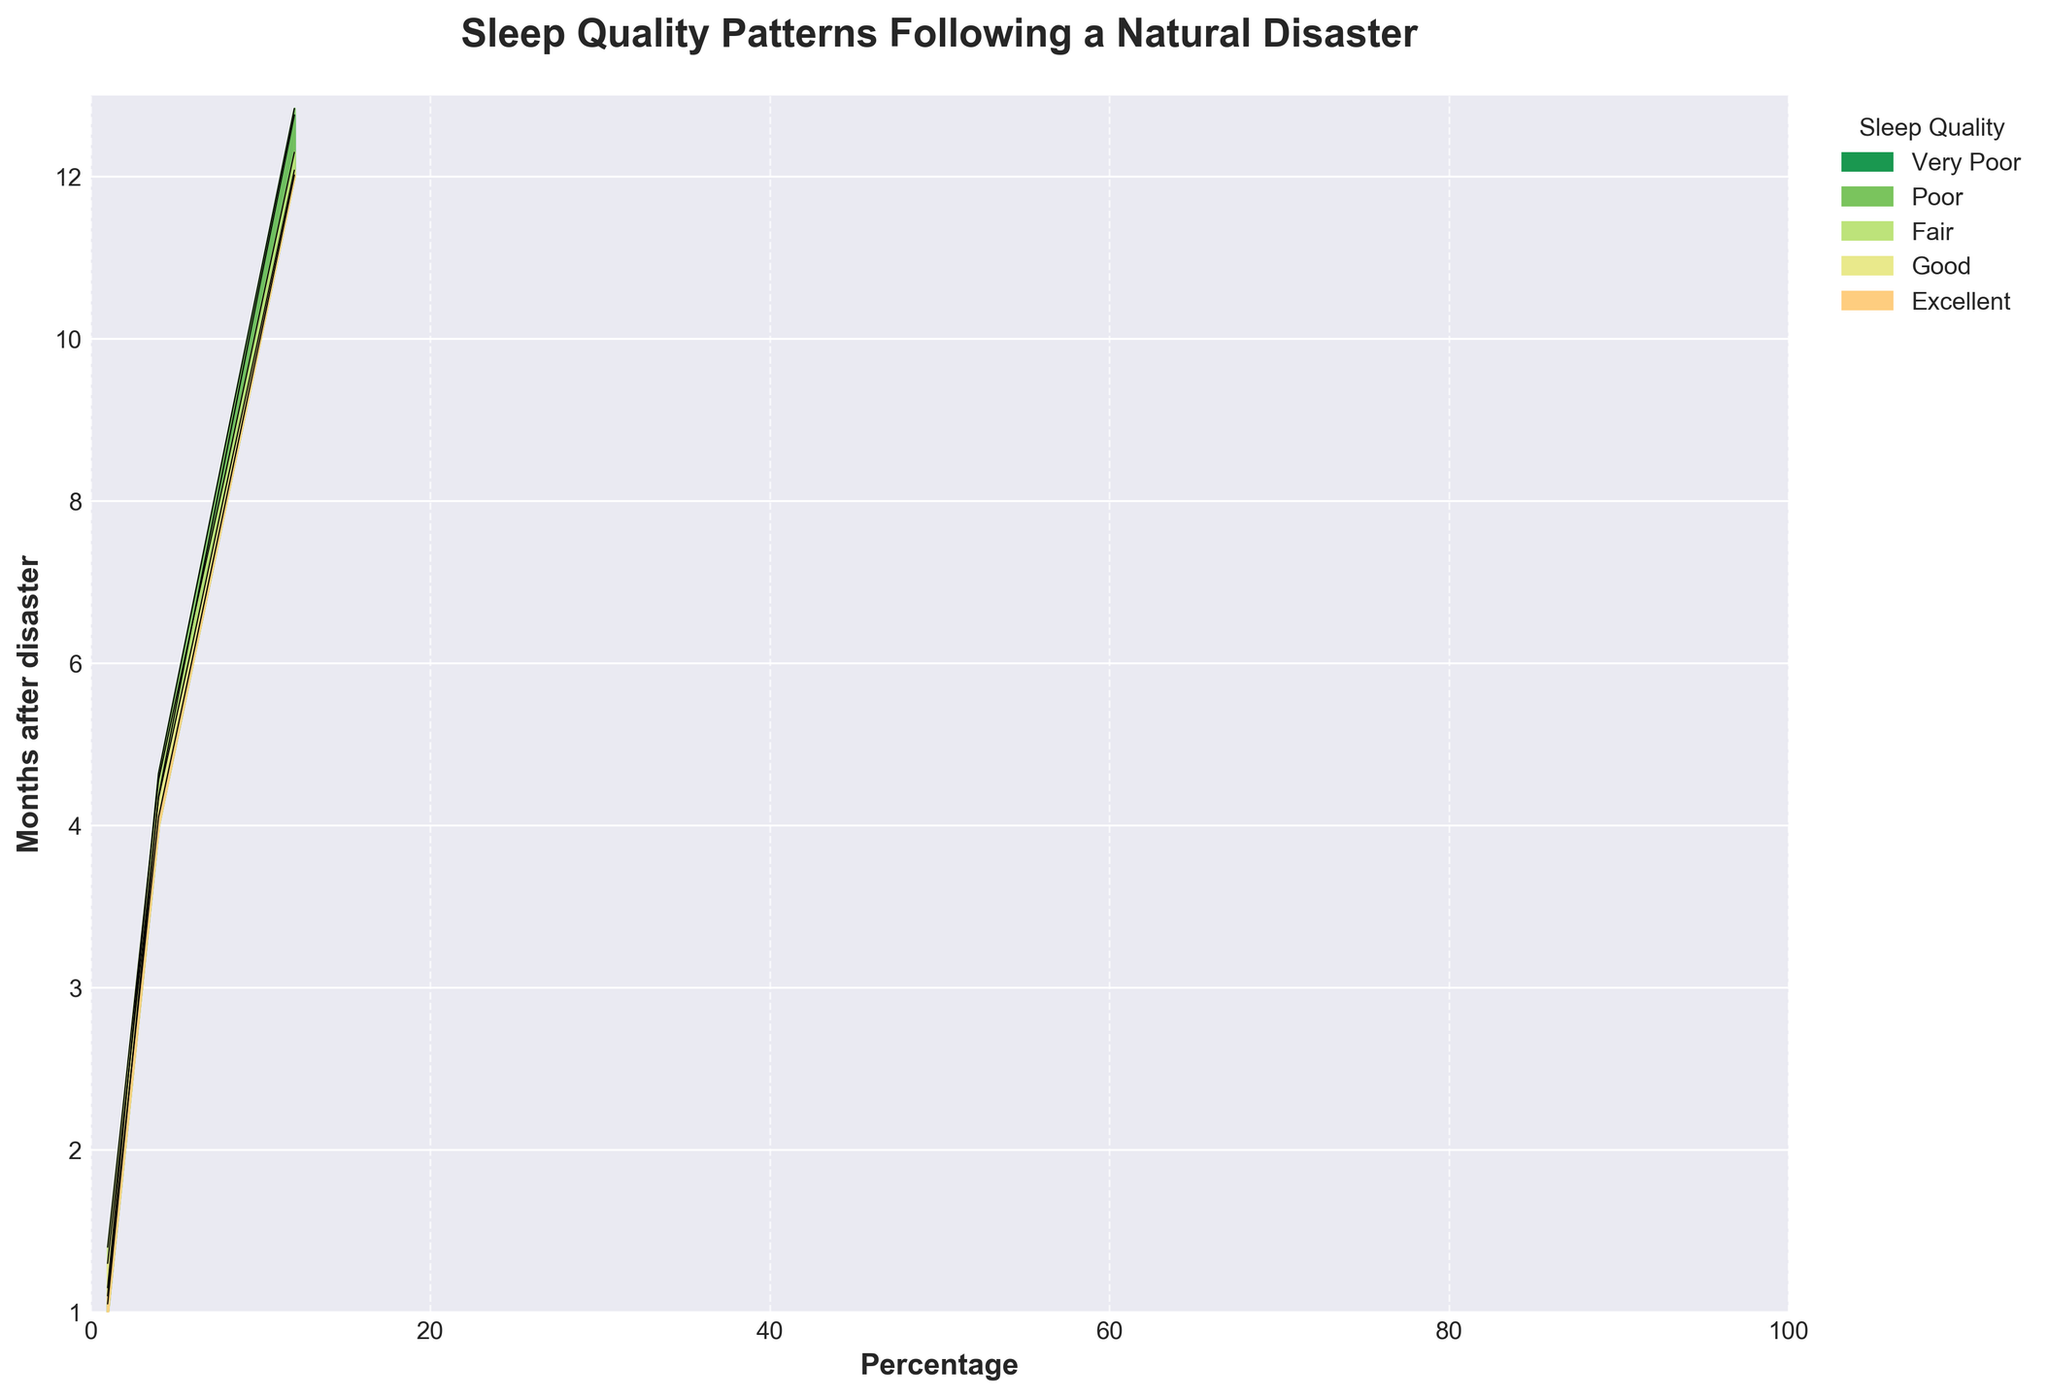What is the title of the plot? The title of the plot is displayed at the top of the figure, indicating the main subject of the data visualization.
Answer: Sleep Quality Patterns Following a Natural Disaster Which axis represents the months after the disaster? The y-axis, labeled "Months after disaster," displays the months from 1 to 12.
Answer: y-axis What are the categories represented in the plot? There are five categories represented in the plot: Excellent, Good, Fair, Poor, and Very Poor. These categories correspond to different levels of sleep quality.
Answer: Excellent, Good, Fair, Poor, Very Poor How does the percentage of individuals reporting 'Poor' sleep quality change from month 1 to month 12? The percentage of individuals reporting 'Poor' sleep quality shows a decreasing trend. It starts at 30% in month 1 and decreases to 4% by month 12.
Answer: Decreases from 30% to 4% Which sleep quality category shows the most improvement over the course of the year? By comparing the changes in percentages over the months, the 'Excellent' category shows the most improvement, increasing from 5% in month 1 to 38% in month 12.
Answer: Excellent In month 4, what is the approximate combined percentage of individuals reporting 'Fair' and 'Poor' sleep quality? In month 4, the percentage for 'Fair' is 28% and for 'Poor' is 17%. Adding these together gives 28% + 17% = 45%.
Answer: 45% By month 10, which two categories have the smallest proportion of individuals? In month 10, the 'Very Poor' category has 1% and the 'Poor' category has 6%. These are the two smallest proportions.
Answer: Very Poor and Poor How does the total percentage of individuals with 'Good' sleep quality change from month 6 to month 8? In month 6, the percentage for 'Good' is 35%, and in month 8, it is 38%. The increase is calculated as 38% - 35% = 3%.
Answer: Increases by 3% What is the trend in the 'Excellent' sleep quality category from month 2 to month 6? The 'Excellent' sleep quality category increases from 8% in month 2 to 25% in month 6, showing a rising trend.
Answer: Increases In month 3, which sleep quality category has the highest percentage of individuals, and what is that percentage? In month 3, the 'Fair' sleep quality category has the highest percentage at 32%.
Answer: Fair, 32% 